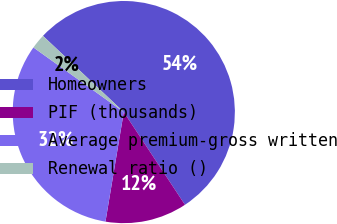<chart> <loc_0><loc_0><loc_500><loc_500><pie_chart><fcel>Homeowners<fcel>PIF (thousands)<fcel>Average premium-gross written<fcel>Renewal ratio ()<nl><fcel>53.68%<fcel>11.92%<fcel>32.24%<fcel>2.15%<nl></chart> 